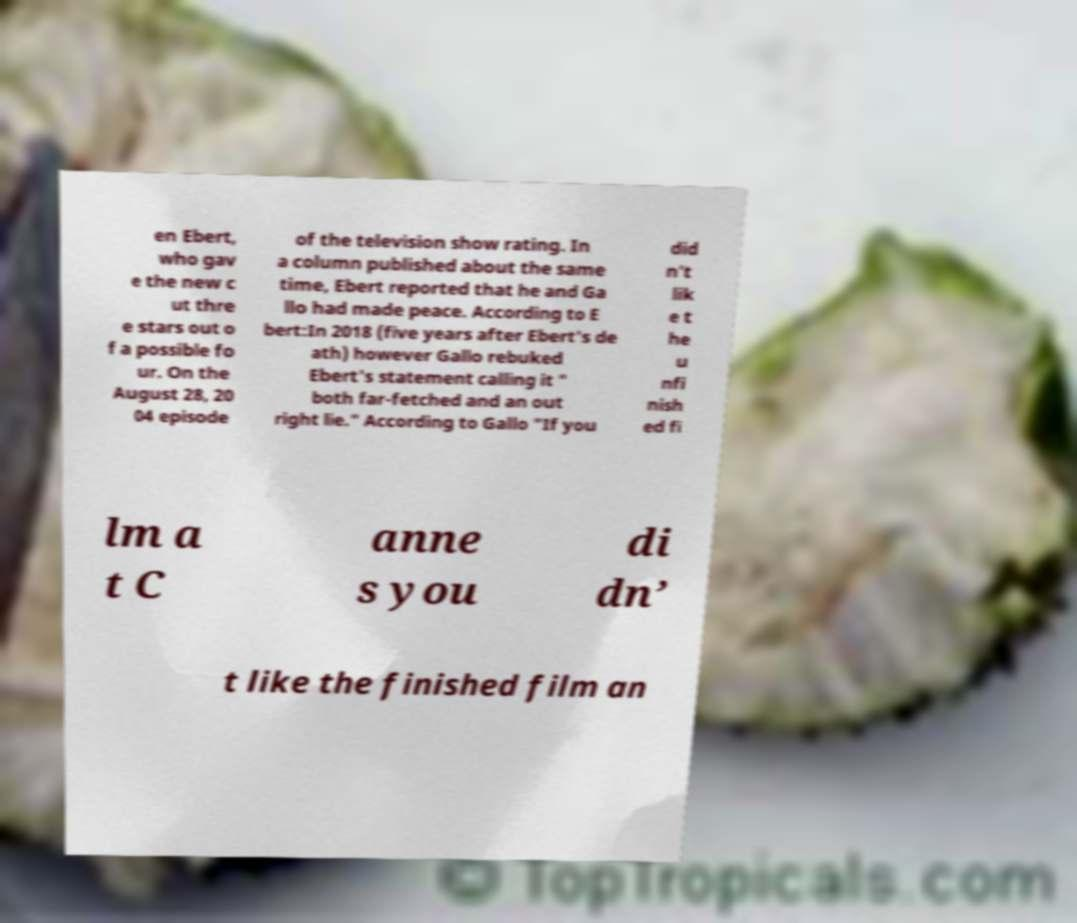There's text embedded in this image that I need extracted. Can you transcribe it verbatim? en Ebert, who gav e the new c ut thre e stars out o f a possible fo ur. On the August 28, 20 04 episode of the television show rating. In a column published about the same time, Ebert reported that he and Ga llo had made peace. According to E bert:In 2018 (five years after Ebert's de ath) however Gallo rebuked Ebert's statement calling it " both far-fetched and an out right lie." According to Gallo "If you did n’t lik e t he u nfi nish ed fi lm a t C anne s you di dn’ t like the finished film an 